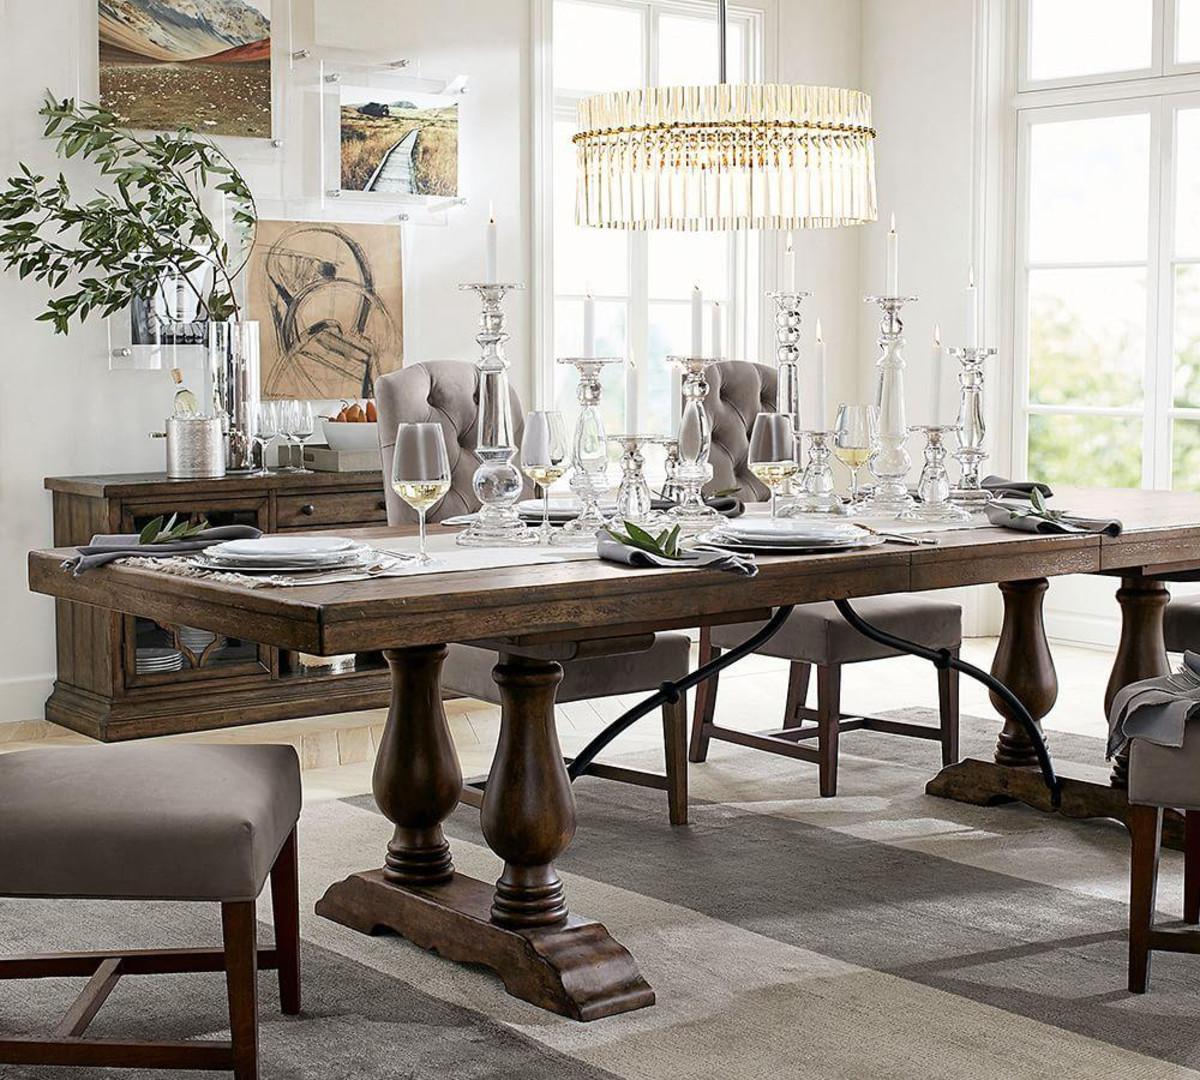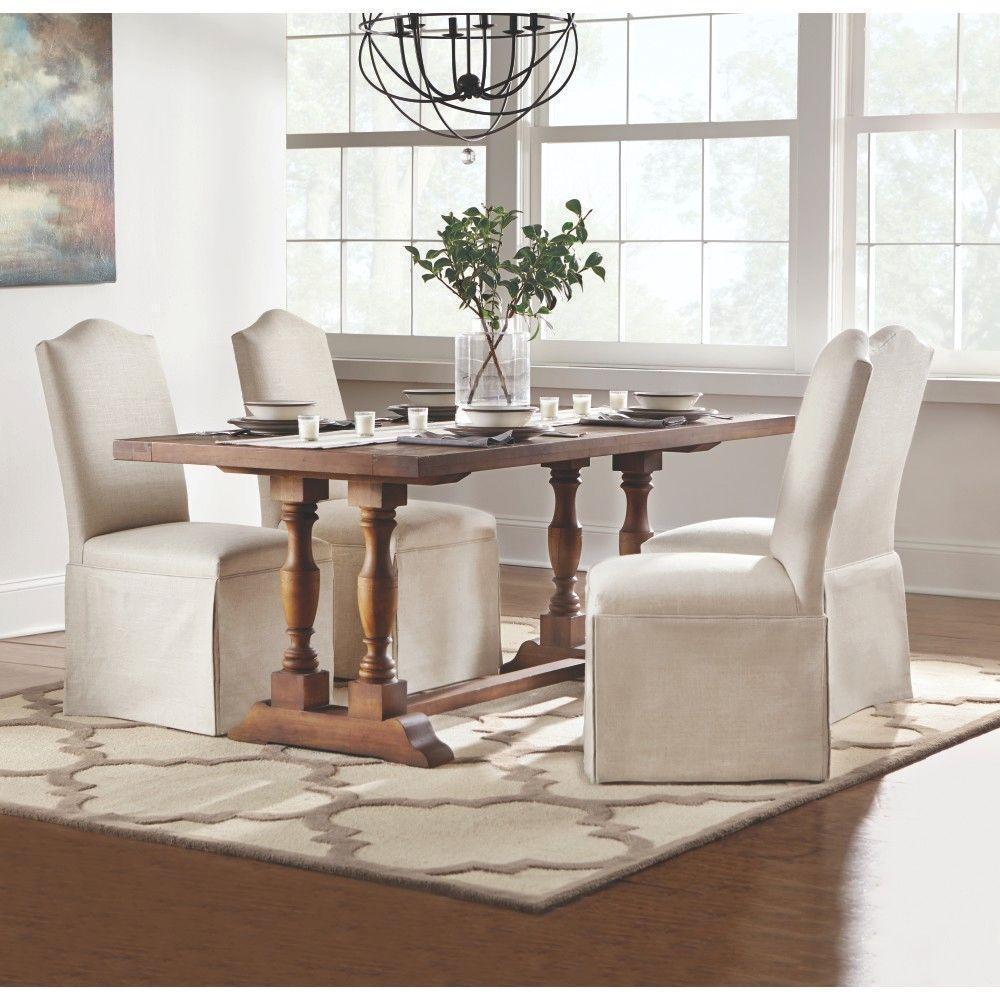The first image is the image on the left, the second image is the image on the right. For the images shown, is this caption "A plant is sitting on the table in the image on the left." true? Answer yes or no. No. 